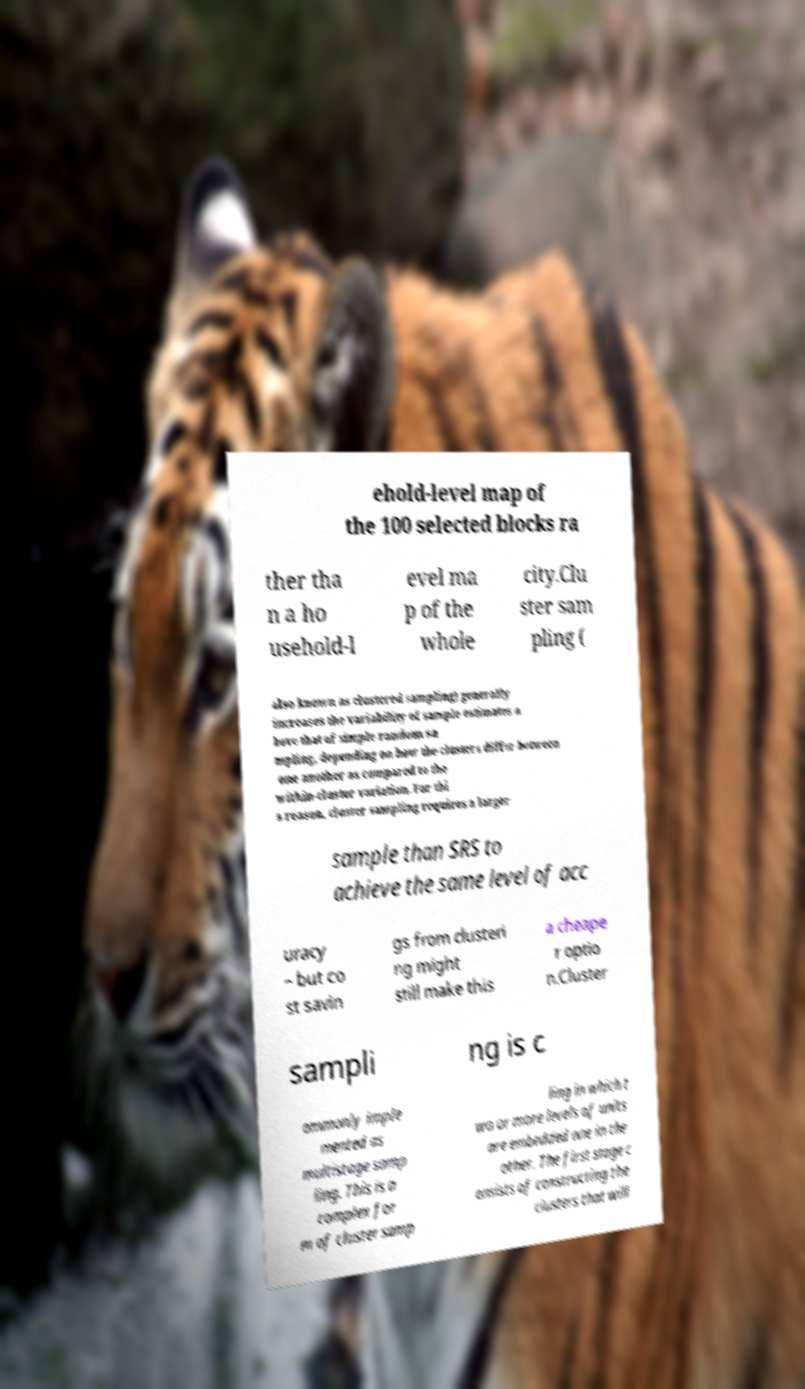There's text embedded in this image that I need extracted. Can you transcribe it verbatim? ehold-level map of the 100 selected blocks ra ther tha n a ho usehold-l evel ma p of the whole city.Clu ster sam pling ( also known as clustered sampling) generally increases the variability of sample estimates a bove that of simple random sa mpling, depending on how the clusters differ between one another as compared to the within-cluster variation. For thi s reason, cluster sampling requires a larger sample than SRS to achieve the same level of acc uracy – but co st savin gs from clusteri ng might still make this a cheape r optio n.Cluster sampli ng is c ommonly imple mented as multistage samp ling. This is a complex for m of cluster samp ling in which t wo or more levels of units are embedded one in the other. The first stage c onsists of constructing the clusters that will 